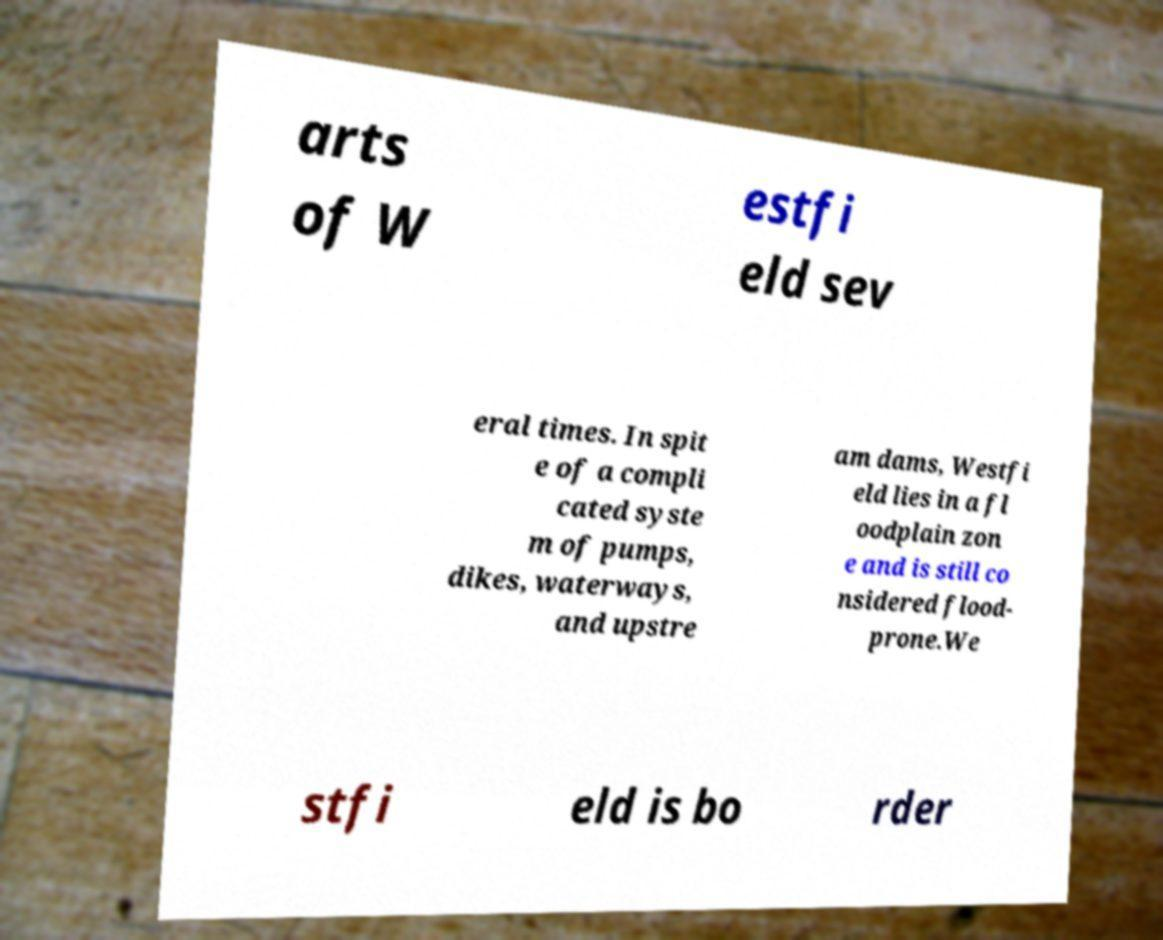Can you read and provide the text displayed in the image?This photo seems to have some interesting text. Can you extract and type it out for me? arts of W estfi eld sev eral times. In spit e of a compli cated syste m of pumps, dikes, waterways, and upstre am dams, Westfi eld lies in a fl oodplain zon e and is still co nsidered flood- prone.We stfi eld is bo rder 